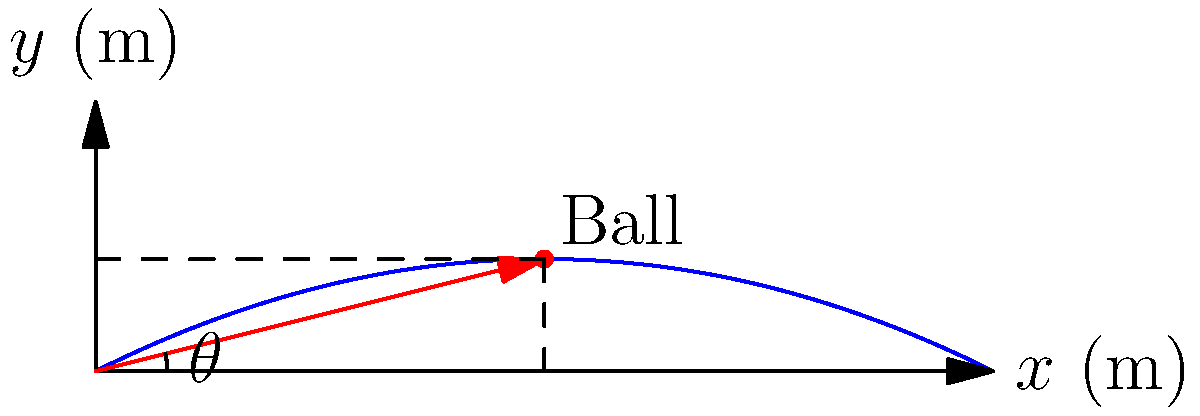During a crucial free kick for Servette FC, the ball's trajectory forms a parabola described by the equation $y = -0.05x^2 + 0.5x$, where $x$ and $y$ are measured in meters. If the ball reaches its maximum height at $x = 5$ meters, what is the initial angle $\theta$ (in degrees) at which the ball was kicked? To find the initial angle $\theta$, we can follow these steps:

1) The slope of the tangent line at the starting point $(0,0)$ represents the tangent of the initial angle. We can find this by taking the derivative of the function at $x = 0$.

2) The function is $y = -0.05x^2 + 0.5x$

3) The derivative is $\frac{dy}{dx} = -0.1x + 0.5$

4) At $x = 0$, $\frac{dy}{dx} = 0.5$

5) Therefore, $\tan(\theta) = 0.5$

6) To find $\theta$, we use the inverse tangent function:

   $\theta = \arctan(0.5)$

7) Converting to degrees:

   $\theta = \arctan(0.5) \cdot \frac{180}{\pi} \approx 26.57°$

Thus, the initial angle of the kick is approximately 26.57 degrees.
Answer: $26.57°$ 